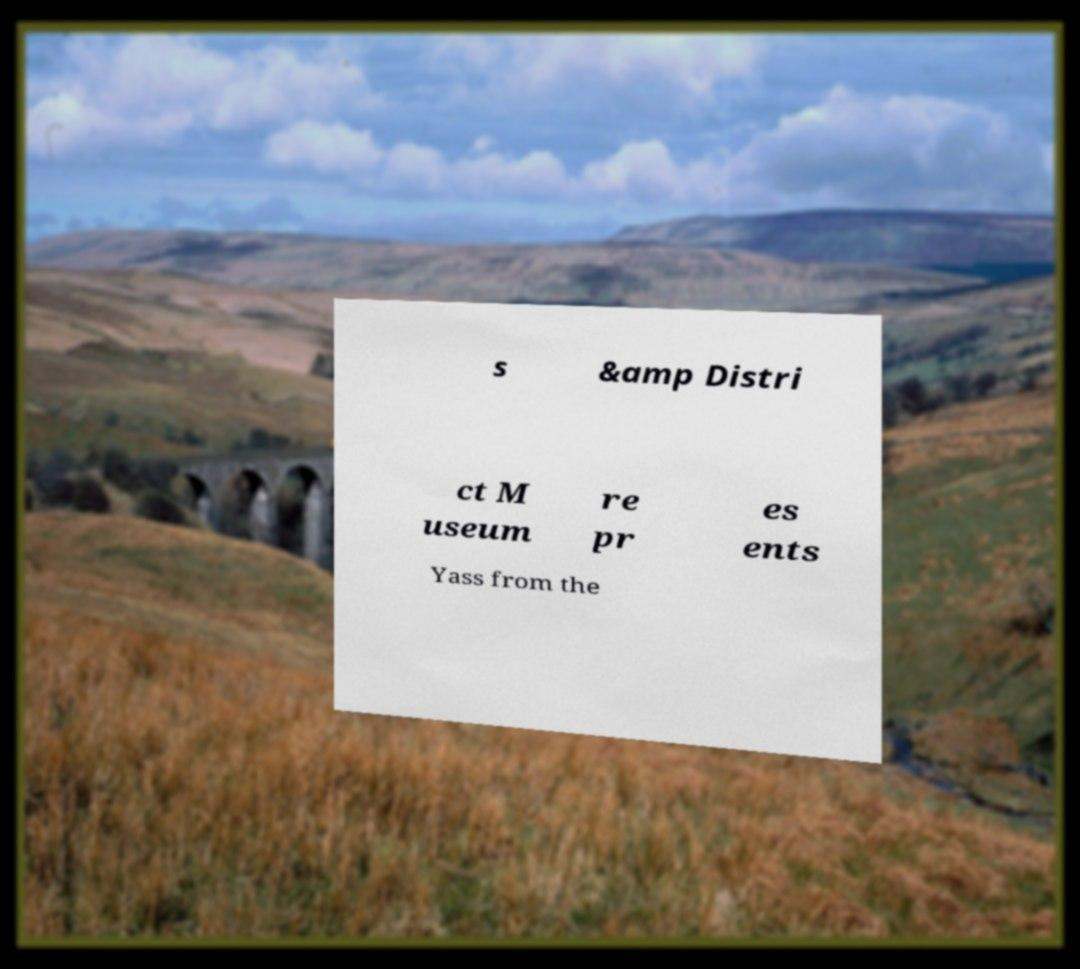Please identify and transcribe the text found in this image. s &amp Distri ct M useum re pr es ents Yass from the 